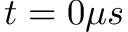<formula> <loc_0><loc_0><loc_500><loc_500>t = 0 \mu s</formula> 